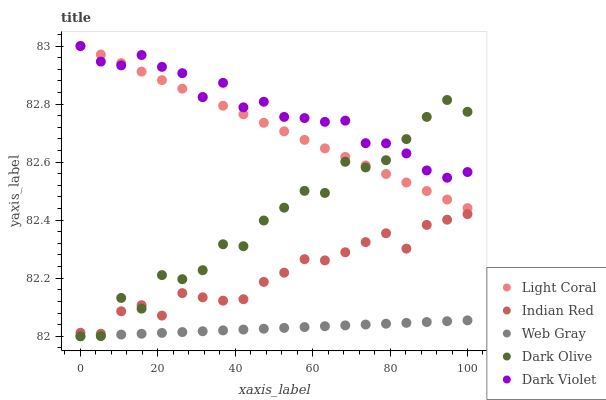Does Web Gray have the minimum area under the curve?
Answer yes or no. Yes. Does Dark Violet have the maximum area under the curve?
Answer yes or no. Yes. Does Dark Olive have the minimum area under the curve?
Answer yes or no. No. Does Dark Olive have the maximum area under the curve?
Answer yes or no. No. Is Light Coral the smoothest?
Answer yes or no. Yes. Is Dark Olive the roughest?
Answer yes or no. Yes. Is Web Gray the smoothest?
Answer yes or no. No. Is Web Gray the roughest?
Answer yes or no. No. Does Web Gray have the lowest value?
Answer yes or no. Yes. Does Dark Violet have the lowest value?
Answer yes or no. No. Does Dark Violet have the highest value?
Answer yes or no. Yes. Does Dark Olive have the highest value?
Answer yes or no. No. Is Web Gray less than Light Coral?
Answer yes or no. Yes. Is Light Coral greater than Indian Red?
Answer yes or no. Yes. Does Light Coral intersect Dark Olive?
Answer yes or no. Yes. Is Light Coral less than Dark Olive?
Answer yes or no. No. Is Light Coral greater than Dark Olive?
Answer yes or no. No. Does Web Gray intersect Light Coral?
Answer yes or no. No. 